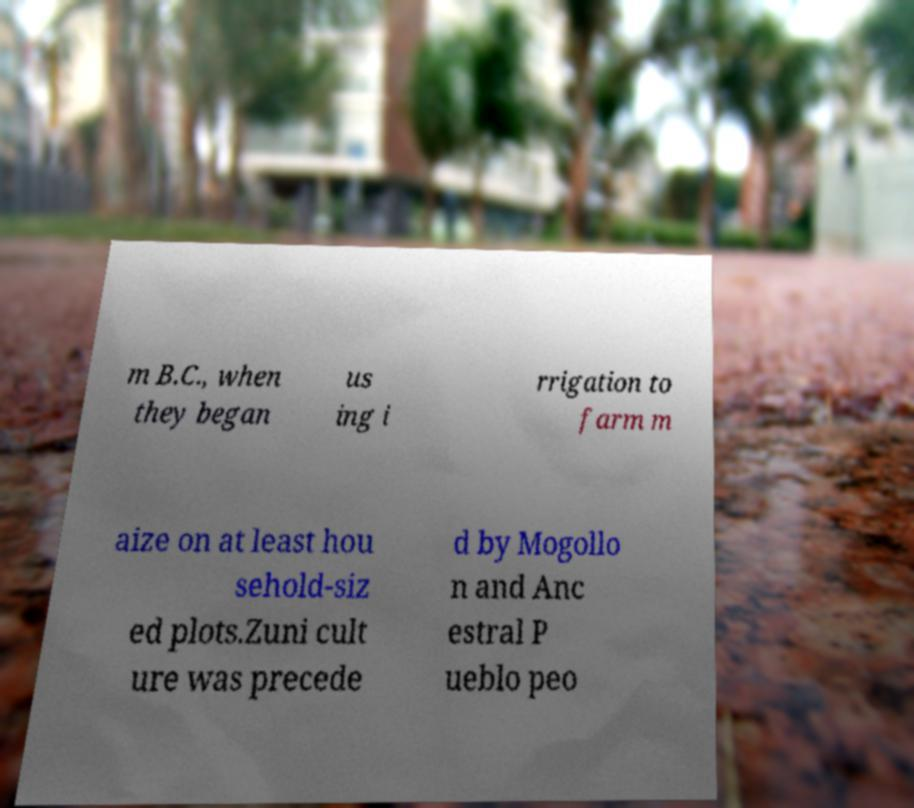Please identify and transcribe the text found in this image. m B.C., when they began us ing i rrigation to farm m aize on at least hou sehold-siz ed plots.Zuni cult ure was precede d by Mogollo n and Anc estral P ueblo peo 